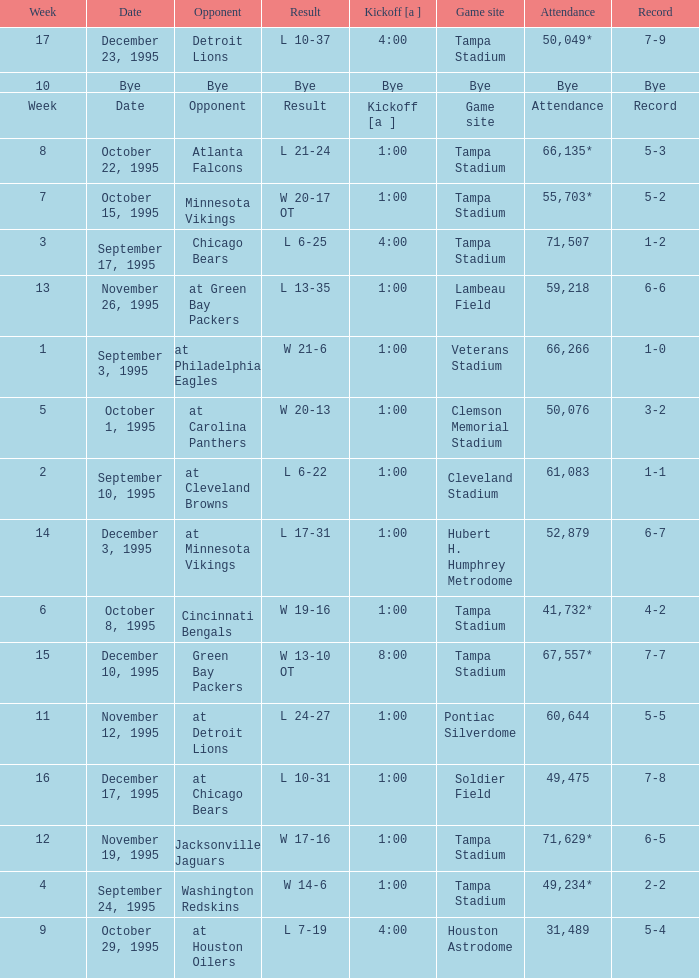Who did the Tampa Bay Buccaneers play on december 23, 1995? Detroit Lions. 